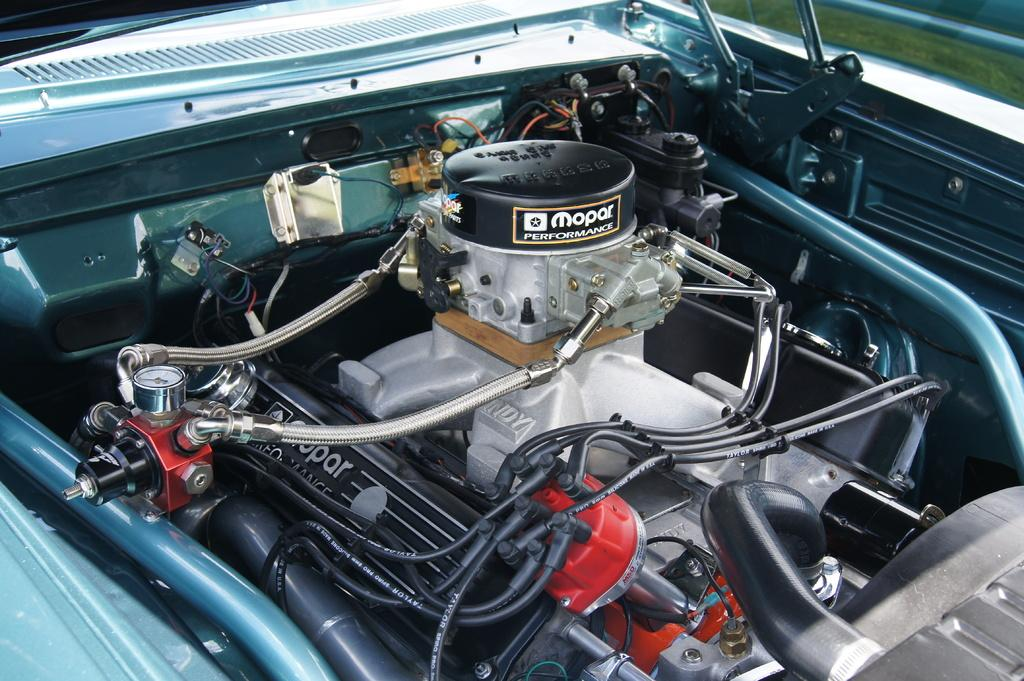What type of object is the main subject in the image? There is a vehicle in the image. What powers the vehicle? The vehicle has a motor and an engine. Are there any visible electrical components on the vehicle? Yes, the vehicle has wires. What direction is the vehicle's sail facing in the image? There is no sail present on the vehicle in the image. What type of teeth can be seen on the vehicle in the image? Vehicles do not have teeth, so there are no teeth visible on the vehicle in the image. 